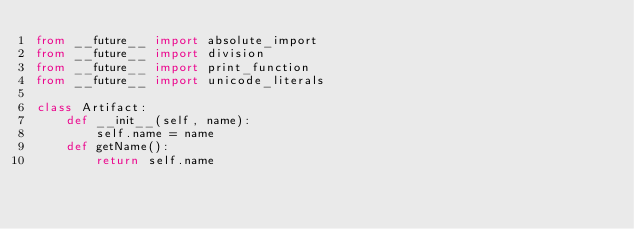Convert code to text. <code><loc_0><loc_0><loc_500><loc_500><_Python_>from __future__ import absolute_import
from __future__ import division
from __future__ import print_function
from __future__ import unicode_literals

class Artifact:
    def __init__(self, name):
        self.name = name
    def getName():
        return self.name
</code> 